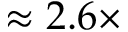Convert formula to latex. <formula><loc_0><loc_0><loc_500><loc_500>\approx 2 . 6 \times</formula> 